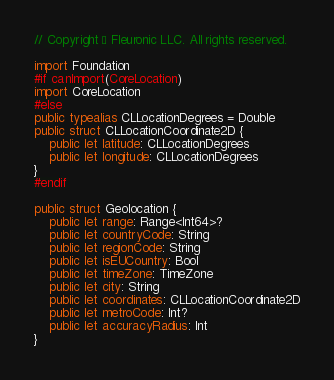Convert code to text. <code><loc_0><loc_0><loc_500><loc_500><_Swift_>// Copyright © Fleuronic LLC. All rights reserved.

import Foundation
#if canImport(CoreLocation)
import CoreLocation
#else
public typealias CLLocationDegrees = Double
public struct CLLocationCoordinate2D {
	public let latitude: CLLocationDegrees
	public let longitude: CLLocationDegrees
}
#endif

public struct Geolocation {
	public let range: Range<Int64>?
	public let countryCode: String
	public let regionCode: String
	public let isEUCountry: Bool
	public let timeZone: TimeZone
	public let city: String
	public let coordinates: CLLocationCoordinate2D
	public let metroCode: Int?
	public let accuracyRadius: Int
}
</code> 